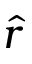Convert formula to latex. <formula><loc_0><loc_0><loc_500><loc_500>\hat { r }</formula> 